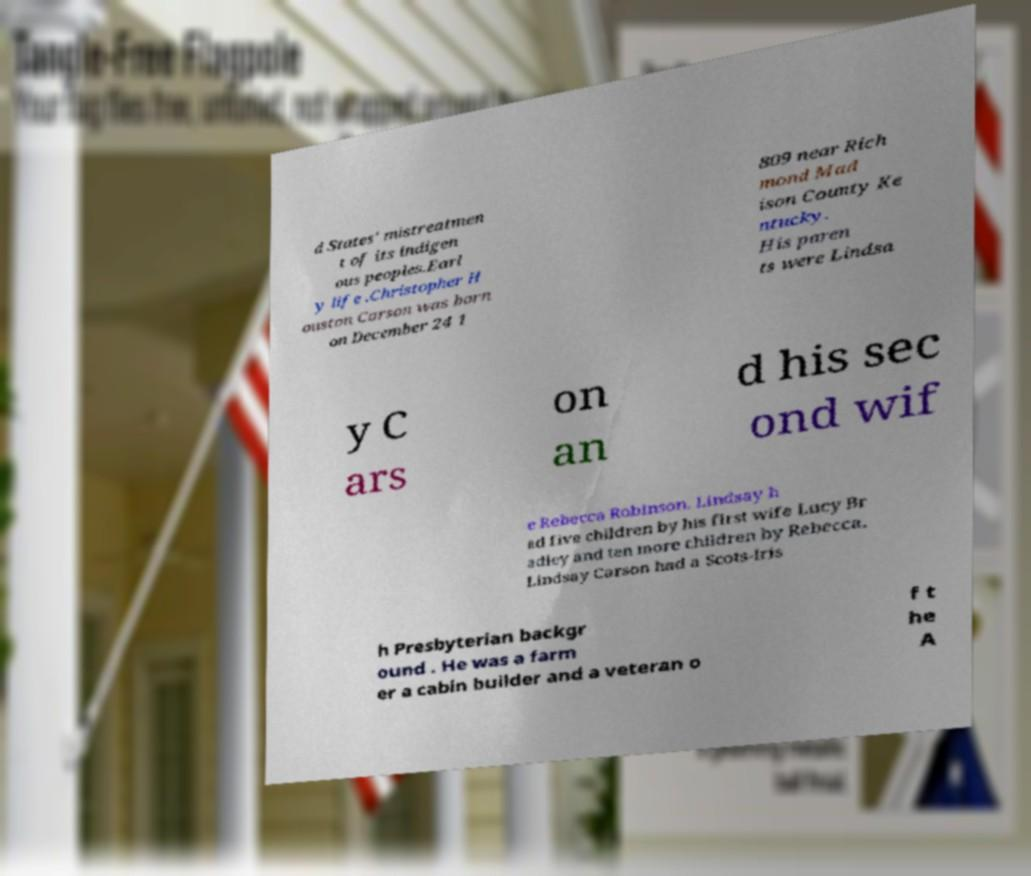I need the written content from this picture converted into text. Can you do that? d States' mistreatmen t of its indigen ous peoples.Earl y life .Christopher H ouston Carson was born on December 24 1 809 near Rich mond Mad ison County Ke ntucky. His paren ts were Lindsa y C ars on an d his sec ond wif e Rebecca Robinson. Lindsay h ad five children by his first wife Lucy Br adley and ten more children by Rebecca. Lindsay Carson had a Scots-Iris h Presbyterian backgr ound . He was a farm er a cabin builder and a veteran o f t he A 